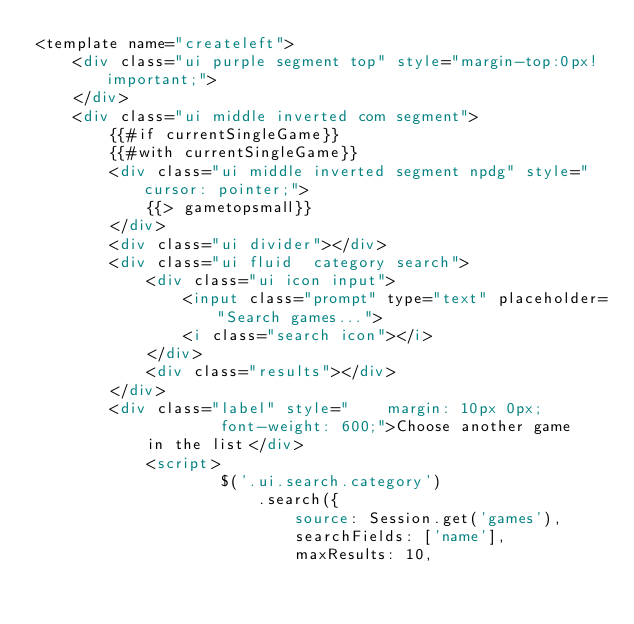Convert code to text. <code><loc_0><loc_0><loc_500><loc_500><_HTML_><template name="createleft">
    <div class="ui purple segment top" style="margin-top:0px!important;">
    </div>
    <div class="ui middle inverted com segment">
        {{#if currentSingleGame}}
        {{#with currentSingleGame}}
        <div class="ui middle inverted segment npdg" style="cursor: pointer;">
            {{> gametopsmall}}
        </div>
        <div class="ui divider"></div>
        <div class="ui fluid  category search">
            <div class="ui icon input">
                <input class="prompt" type="text" placeholder="Search games...">
                <i class="search icon"></i>
            </div>
            <div class="results"></div>
        </div>
        <div class="label" style="    margin: 10px 0px;
                    font-weight: 600;">Choose another game
            in the list</div>
            <script>
                    $('.ui.search.category')
                        .search({
                            source: Session.get('games'),
                            searchFields: ['name'],
                            maxResults: 10,</code> 